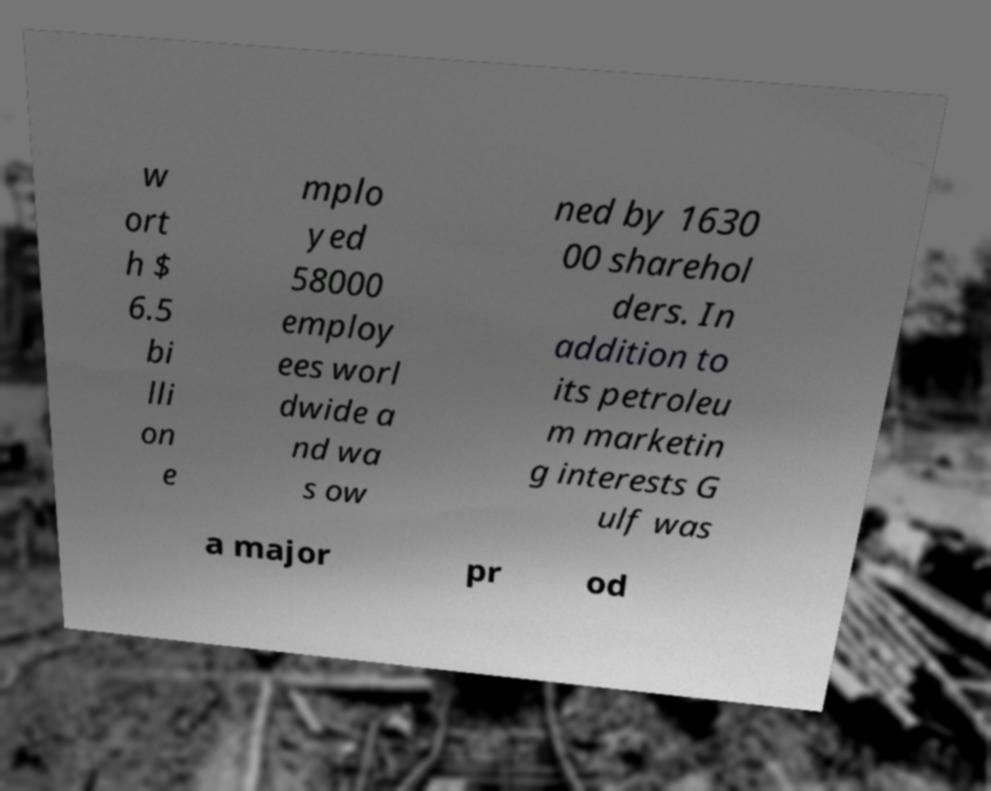There's text embedded in this image that I need extracted. Can you transcribe it verbatim? w ort h $ 6.5 bi lli on e mplo yed 58000 employ ees worl dwide a nd wa s ow ned by 1630 00 sharehol ders. In addition to its petroleu m marketin g interests G ulf was a major pr od 